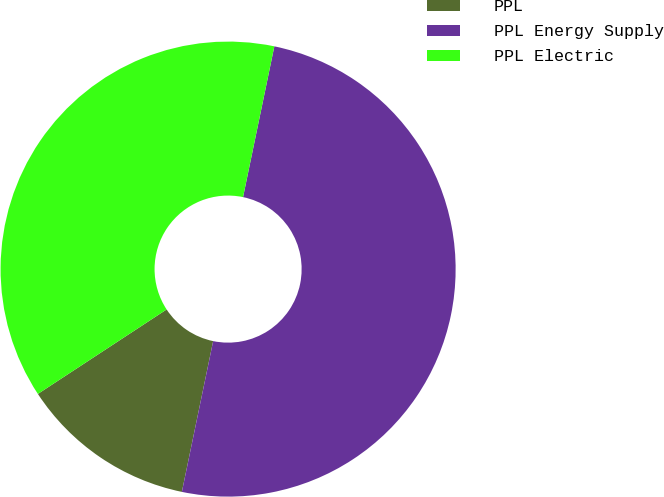Convert chart. <chart><loc_0><loc_0><loc_500><loc_500><pie_chart><fcel>PPL<fcel>PPL Energy Supply<fcel>PPL Electric<nl><fcel>12.5%<fcel>50.0%<fcel>37.5%<nl></chart> 